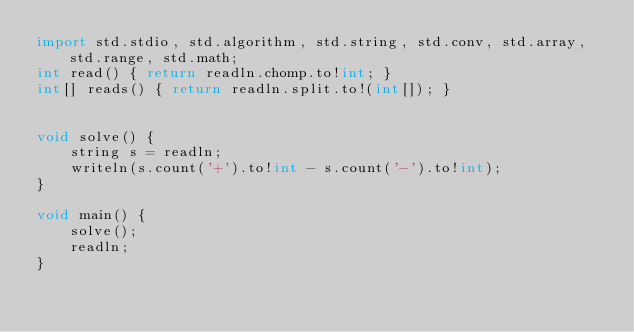<code> <loc_0><loc_0><loc_500><loc_500><_D_>import std.stdio, std.algorithm, std.string, std.conv, std.array, std.range, std.math;
int read() { return readln.chomp.to!int; }
int[] reads() { return readln.split.to!(int[]); }


void solve() {
    string s = readln;
    writeln(s.count('+').to!int - s.count('-').to!int);
}

void main() {
    solve();
    readln;
}</code> 